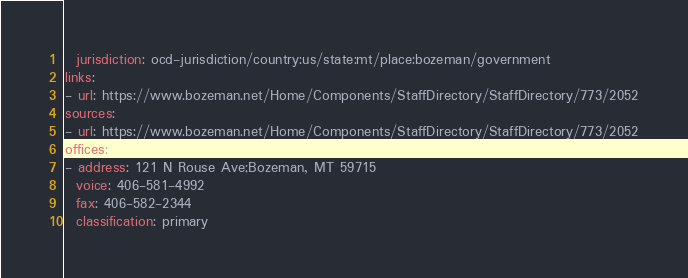Convert code to text. <code><loc_0><loc_0><loc_500><loc_500><_YAML_>  jurisdiction: ocd-jurisdiction/country:us/state:mt/place:bozeman/government
links:
- url: https://www.bozeman.net/Home/Components/StaffDirectory/StaffDirectory/773/2052
sources:
- url: https://www.bozeman.net/Home/Components/StaffDirectory/StaffDirectory/773/2052
offices:
- address: 121 N Rouse Ave;Bozeman, MT 59715
  voice: 406-581-4992
  fax: 406-582-2344
  classification: primary
</code> 